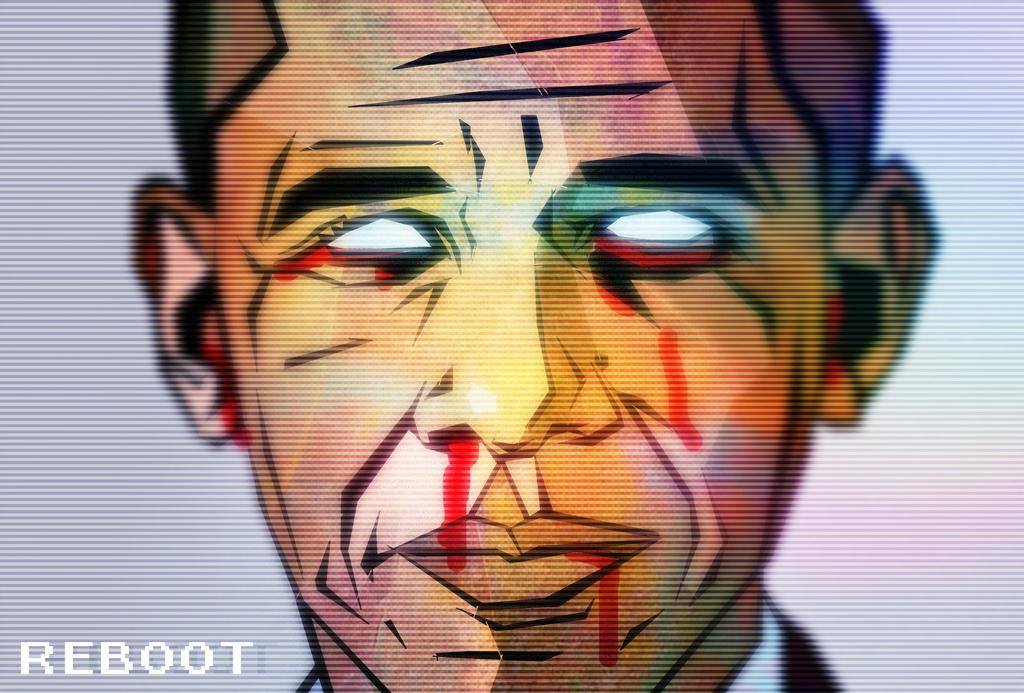What is the main subject of the image? The main subject of the image is an animated face of a person. Can you describe the appearance of the face in the image? The face in the image is animated, which means it may have exaggerated or cartoonish features. What type of soap is being used to clean the wool in the image? There is no soap or wool present in the image; it only features an animated face of a person. 